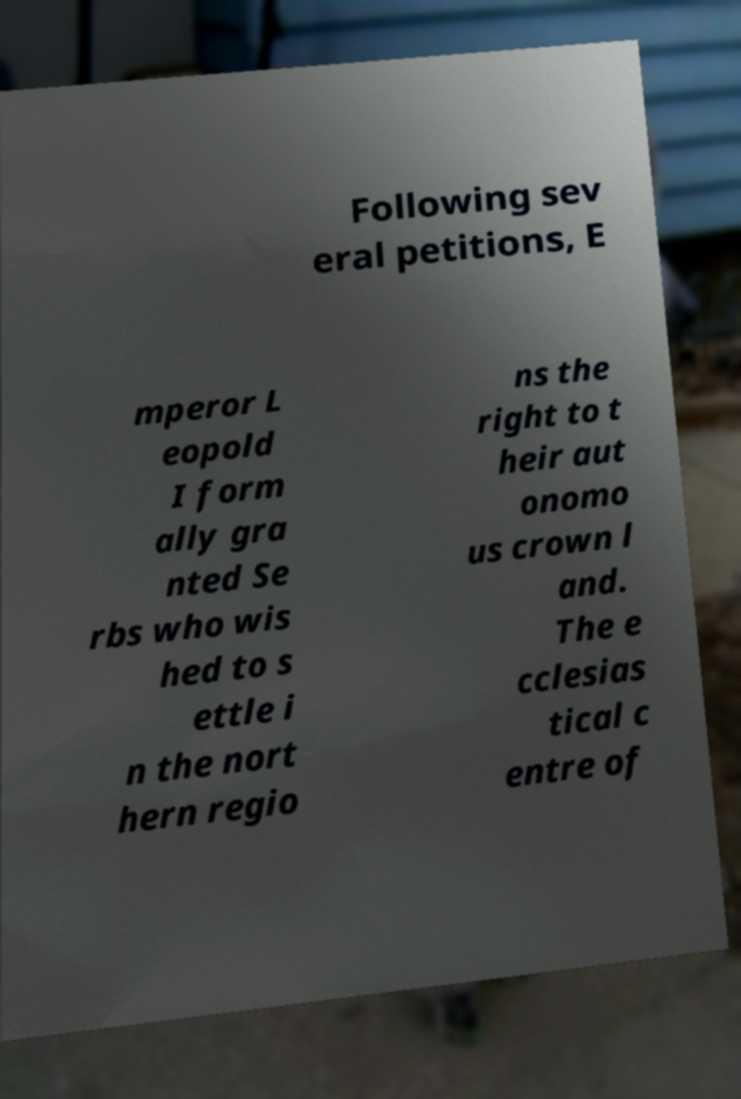There's text embedded in this image that I need extracted. Can you transcribe it verbatim? Following sev eral petitions, E mperor L eopold I form ally gra nted Se rbs who wis hed to s ettle i n the nort hern regio ns the right to t heir aut onomo us crown l and. The e cclesias tical c entre of 